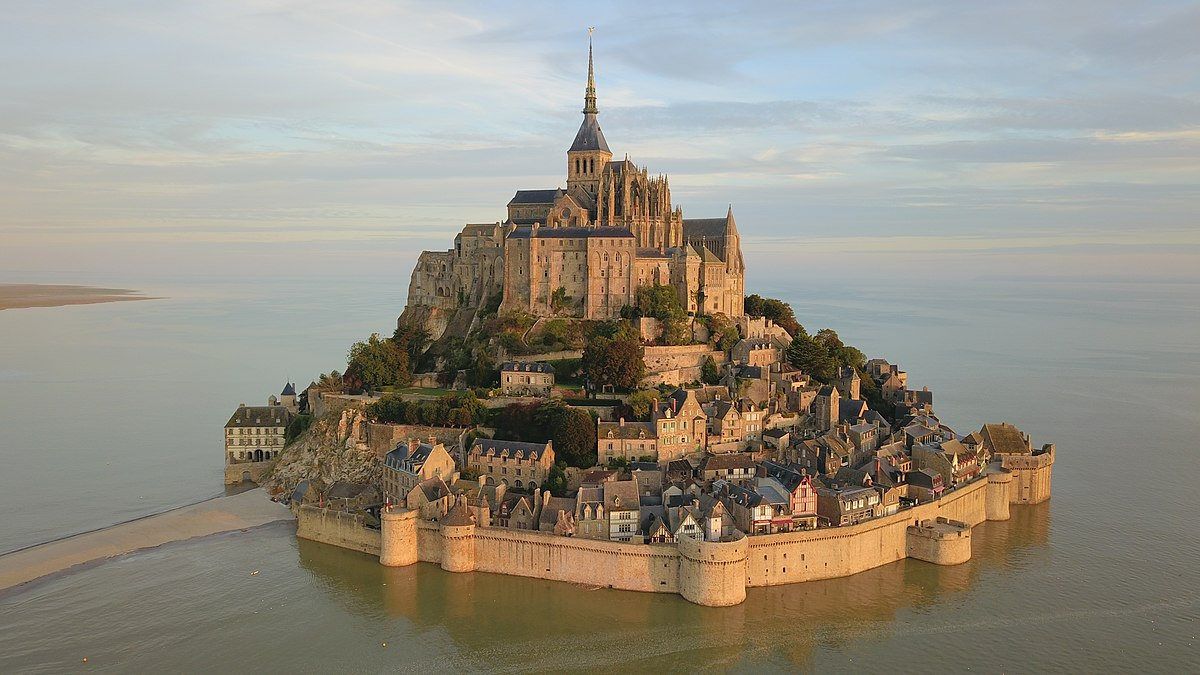Imagine if Mont St Michel could talk. What stories would it tell about its past? If Mont St Michel could talk, it would regale us with tales of divine visions and heavenly mandates, beginning with the mysterious appearance of the archangel Michael to Bishop Aubert. It would recount the relentless efforts of medieval architects and workers who toiled for centuries to elevate the abbey and fortifications. Mont St Michel would share the strategic military maneuvers it witnessed, as soldiers defended its sacred grounds from invaders during the Hundred Years' War. The island would speak of scholars and monks who, through centuries, turned its halls into a beacon of learning and spiritual introspection. Stories of pilgrims and travelers from all eras, drawn by faith or curiosity, would fill its narrative, each contributing to the island's multifaceted history. The whispers of the tides, which daily encircle and isolate the island, would echo the timeless cycles of nature, resilience, and the indomitable spirit of the human quest for meaning and protection. Mont St Michel’s stories would be a blend of mystical, historical, and deeply human experiences, all knitted together by the enduring stone walls and ethereal beauty it proudly displays. 